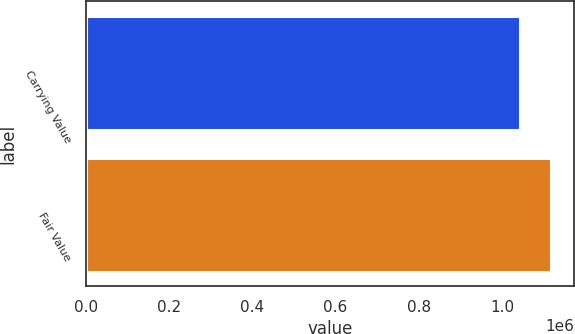<chart> <loc_0><loc_0><loc_500><loc_500><bar_chart><fcel>Carrying Value<fcel>Fair Value<nl><fcel>1.04295e+06<fcel>1.118e+06<nl></chart> 